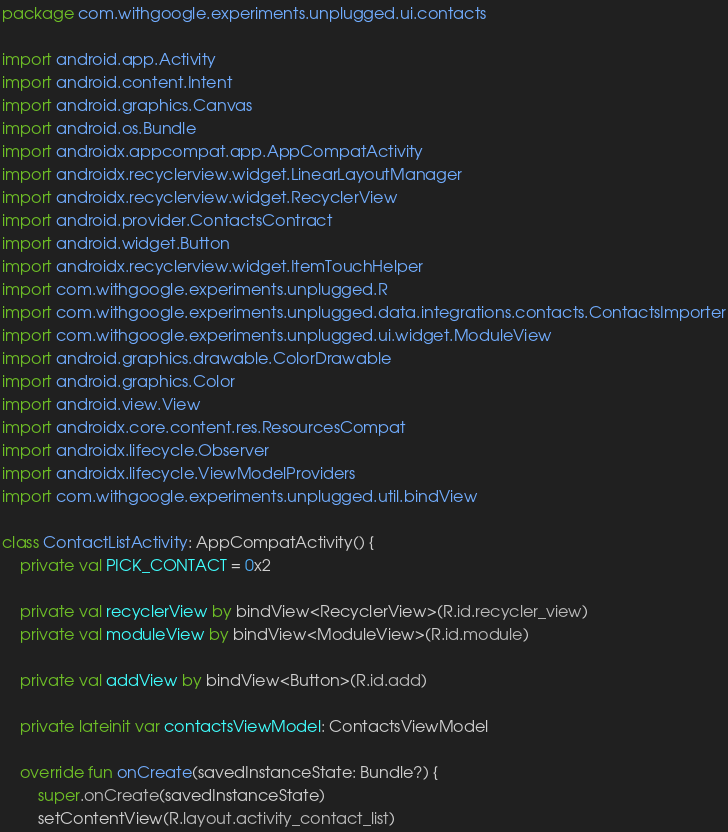<code> <loc_0><loc_0><loc_500><loc_500><_Kotlin_>package com.withgoogle.experiments.unplugged.ui.contacts

import android.app.Activity
import android.content.Intent
import android.graphics.Canvas
import android.os.Bundle
import androidx.appcompat.app.AppCompatActivity
import androidx.recyclerview.widget.LinearLayoutManager
import androidx.recyclerview.widget.RecyclerView
import android.provider.ContactsContract
import android.widget.Button
import androidx.recyclerview.widget.ItemTouchHelper
import com.withgoogle.experiments.unplugged.R
import com.withgoogle.experiments.unplugged.data.integrations.contacts.ContactsImporter
import com.withgoogle.experiments.unplugged.ui.widget.ModuleView
import android.graphics.drawable.ColorDrawable
import android.graphics.Color
import android.view.View
import androidx.core.content.res.ResourcesCompat
import androidx.lifecycle.Observer
import androidx.lifecycle.ViewModelProviders
import com.withgoogle.experiments.unplugged.util.bindView

class ContactListActivity: AppCompatActivity() {
    private val PICK_CONTACT = 0x2

    private val recyclerView by bindView<RecyclerView>(R.id.recycler_view)
    private val moduleView by bindView<ModuleView>(R.id.module)

    private val addView by bindView<Button>(R.id.add)

    private lateinit var contactsViewModel: ContactsViewModel

    override fun onCreate(savedInstanceState: Bundle?) {
        super.onCreate(savedInstanceState)
        setContentView(R.layout.activity_contact_list)
</code> 